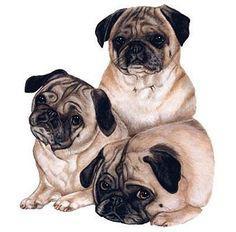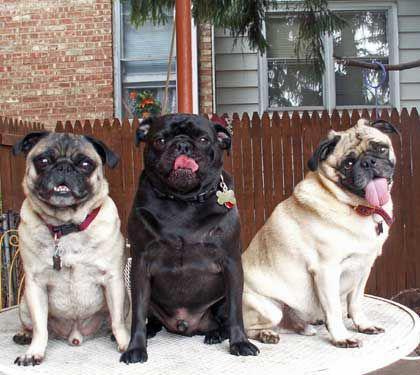The first image is the image on the left, the second image is the image on the right. Considering the images on both sides, is "The left image contains a row of three pugs, and the right image shows one pug lying flat." valid? Answer yes or no. No. The first image is the image on the left, the second image is the image on the right. Assess this claim about the two images: "There are exactly four dogs in total.". Correct or not? Answer yes or no. No. 